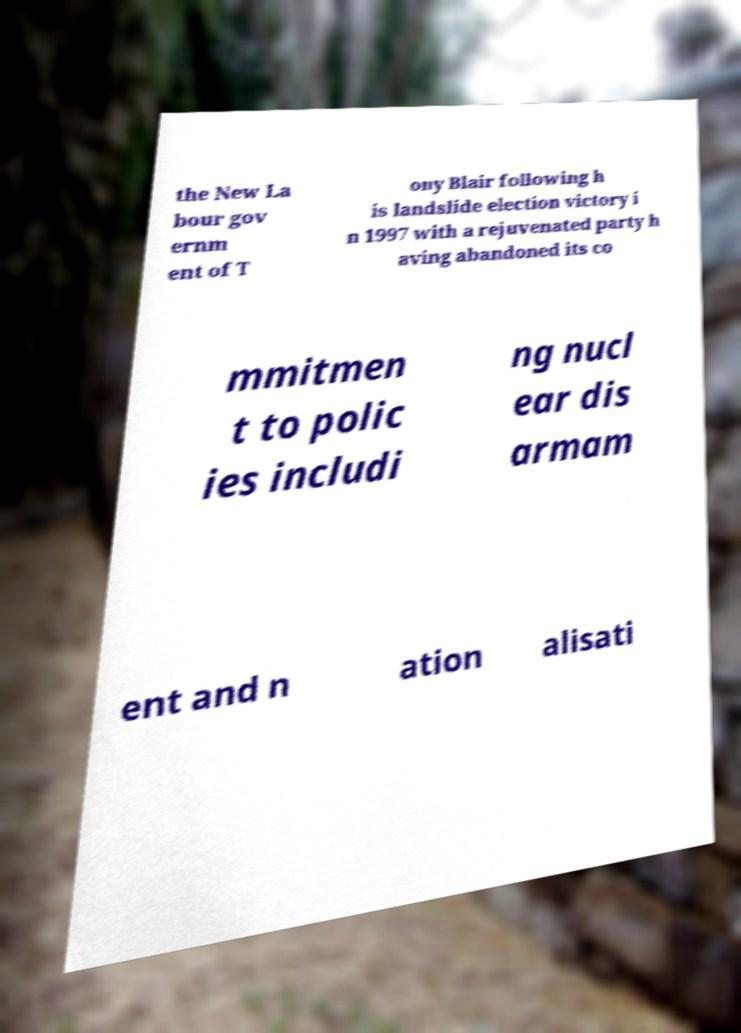Can you accurately transcribe the text from the provided image for me? the New La bour gov ernm ent of T ony Blair following h is landslide election victory i n 1997 with a rejuvenated party h aving abandoned its co mmitmen t to polic ies includi ng nucl ear dis armam ent and n ation alisati 